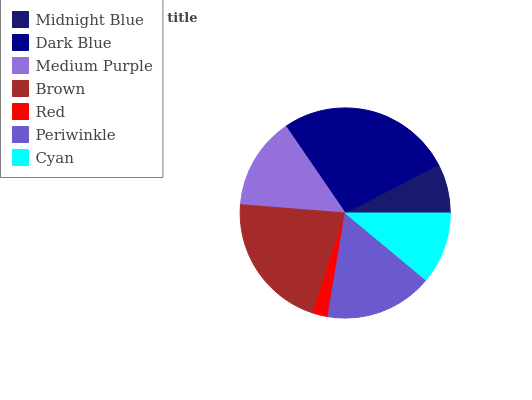Is Red the minimum?
Answer yes or no. Yes. Is Dark Blue the maximum?
Answer yes or no. Yes. Is Medium Purple the minimum?
Answer yes or no. No. Is Medium Purple the maximum?
Answer yes or no. No. Is Dark Blue greater than Medium Purple?
Answer yes or no. Yes. Is Medium Purple less than Dark Blue?
Answer yes or no. Yes. Is Medium Purple greater than Dark Blue?
Answer yes or no. No. Is Dark Blue less than Medium Purple?
Answer yes or no. No. Is Medium Purple the high median?
Answer yes or no. Yes. Is Medium Purple the low median?
Answer yes or no. Yes. Is Brown the high median?
Answer yes or no. No. Is Midnight Blue the low median?
Answer yes or no. No. 